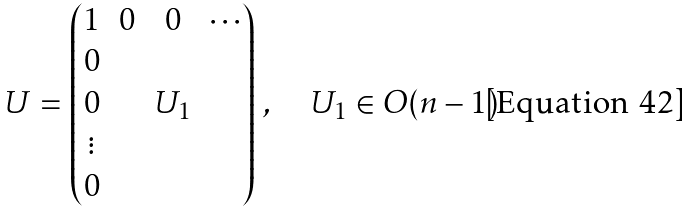<formula> <loc_0><loc_0><loc_500><loc_500>U = \begin{pmatrix} 1 & 0 & 0 & \cdots \\ 0 & & & \\ 0 & & U _ { 1 } & \\ \vdots & & & \\ 0 & & & \end{pmatrix} \, , \quad U _ { 1 } \in O ( n - 1 )</formula> 